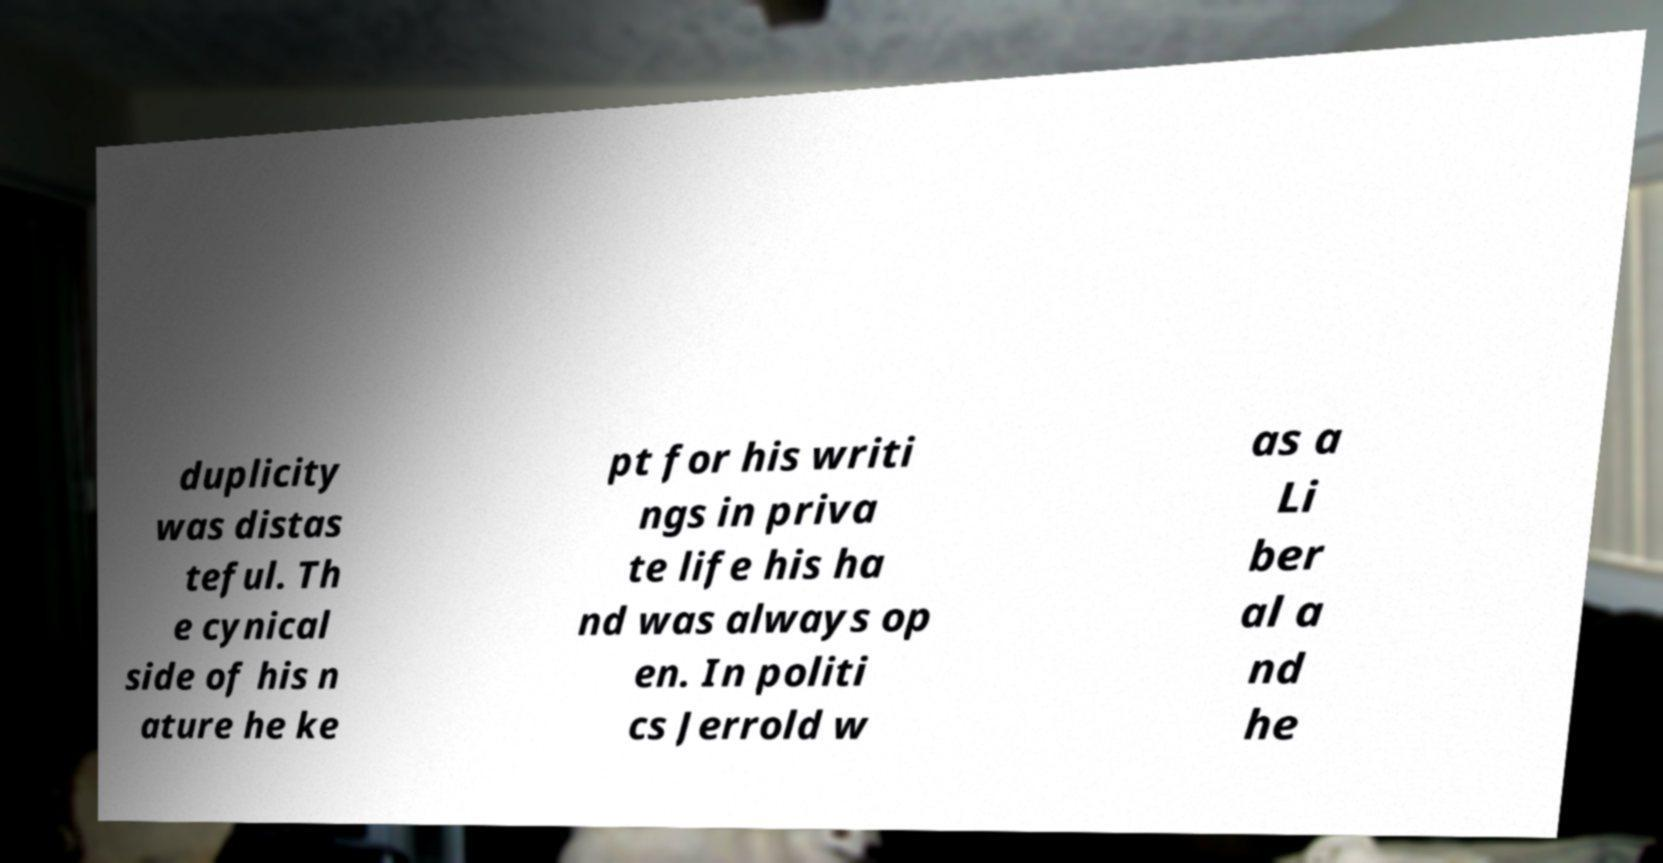Can you read and provide the text displayed in the image?This photo seems to have some interesting text. Can you extract and type it out for me? duplicity was distas teful. Th e cynical side of his n ature he ke pt for his writi ngs in priva te life his ha nd was always op en. In politi cs Jerrold w as a Li ber al a nd he 